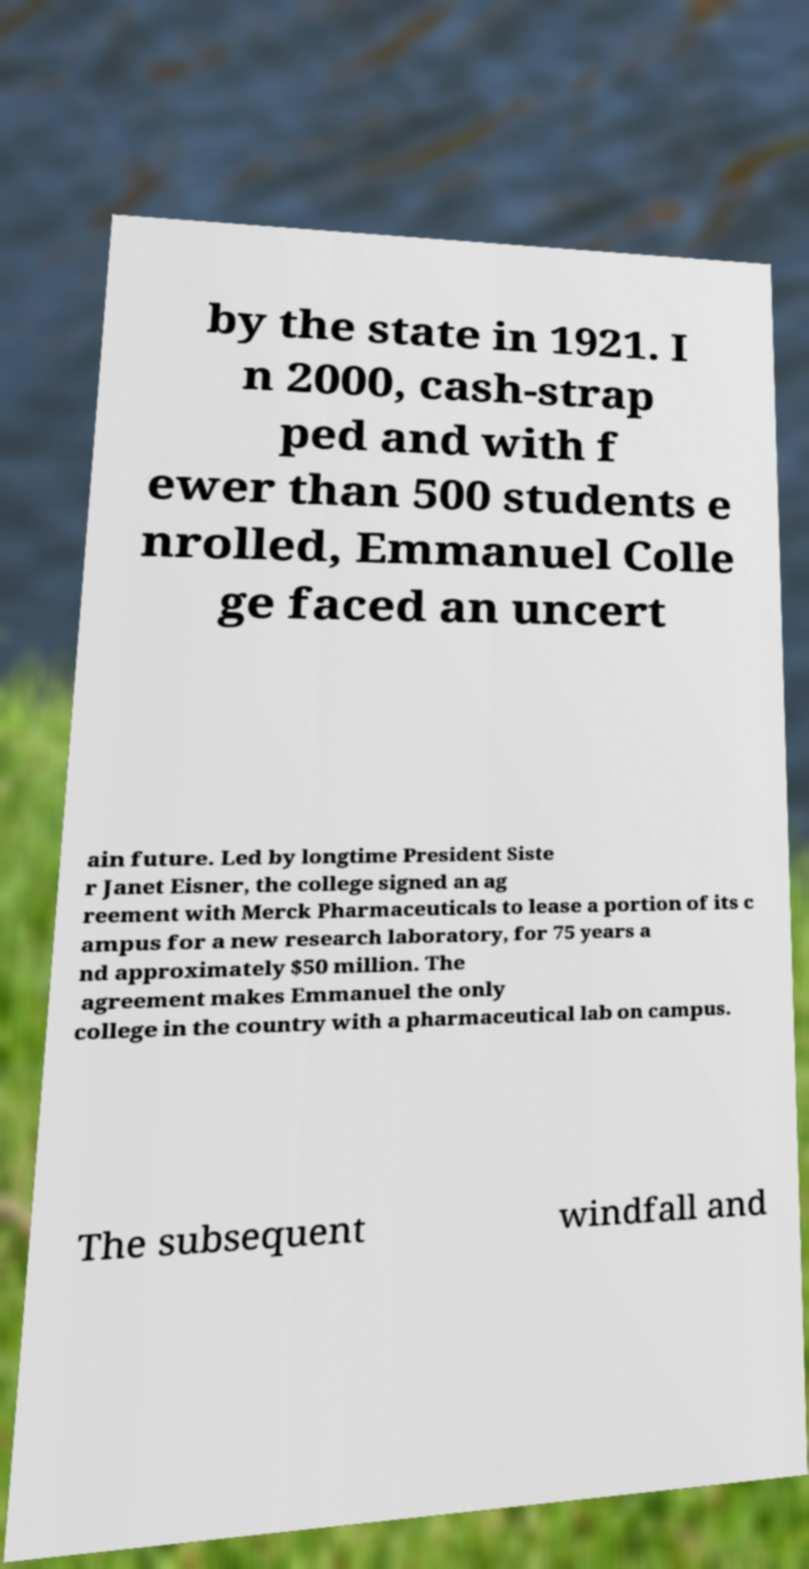I need the written content from this picture converted into text. Can you do that? by the state in 1921. I n 2000, cash-strap ped and with f ewer than 500 students e nrolled, Emmanuel Colle ge faced an uncert ain future. Led by longtime President Siste r Janet Eisner, the college signed an ag reement with Merck Pharmaceuticals to lease a portion of its c ampus for a new research laboratory, for 75 years a nd approximately $50 million. The agreement makes Emmanuel the only college in the country with a pharmaceutical lab on campus. The subsequent windfall and 